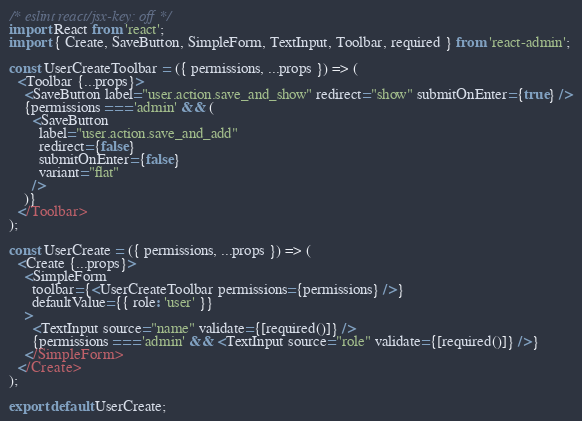<code> <loc_0><loc_0><loc_500><loc_500><_JavaScript_>/* eslint react/jsx-key: off */
import React from 'react';
import { Create, SaveButton, SimpleForm, TextInput, Toolbar, required } from 'react-admin';

const UserCreateToolbar = ({ permissions, ...props }) => (
  <Toolbar {...props}>
    <SaveButton label="user.action.save_and_show" redirect="show" submitOnEnter={true} />
    {permissions === 'admin' && (
      <SaveButton
        label="user.action.save_and_add"
        redirect={false}
        submitOnEnter={false}
        variant="flat"
      />
    )}
  </Toolbar>
);

const UserCreate = ({ permissions, ...props }) => (
  <Create {...props}>
    <SimpleForm
      toolbar={<UserCreateToolbar permissions={permissions} />}
      defaultValue={{ role: 'user' }}
    >
      <TextInput source="name" validate={[required()]} />
      {permissions === 'admin' && <TextInput source="role" validate={[required()]} />}
    </SimpleForm>
  </Create>
);

export default UserCreate;
</code> 